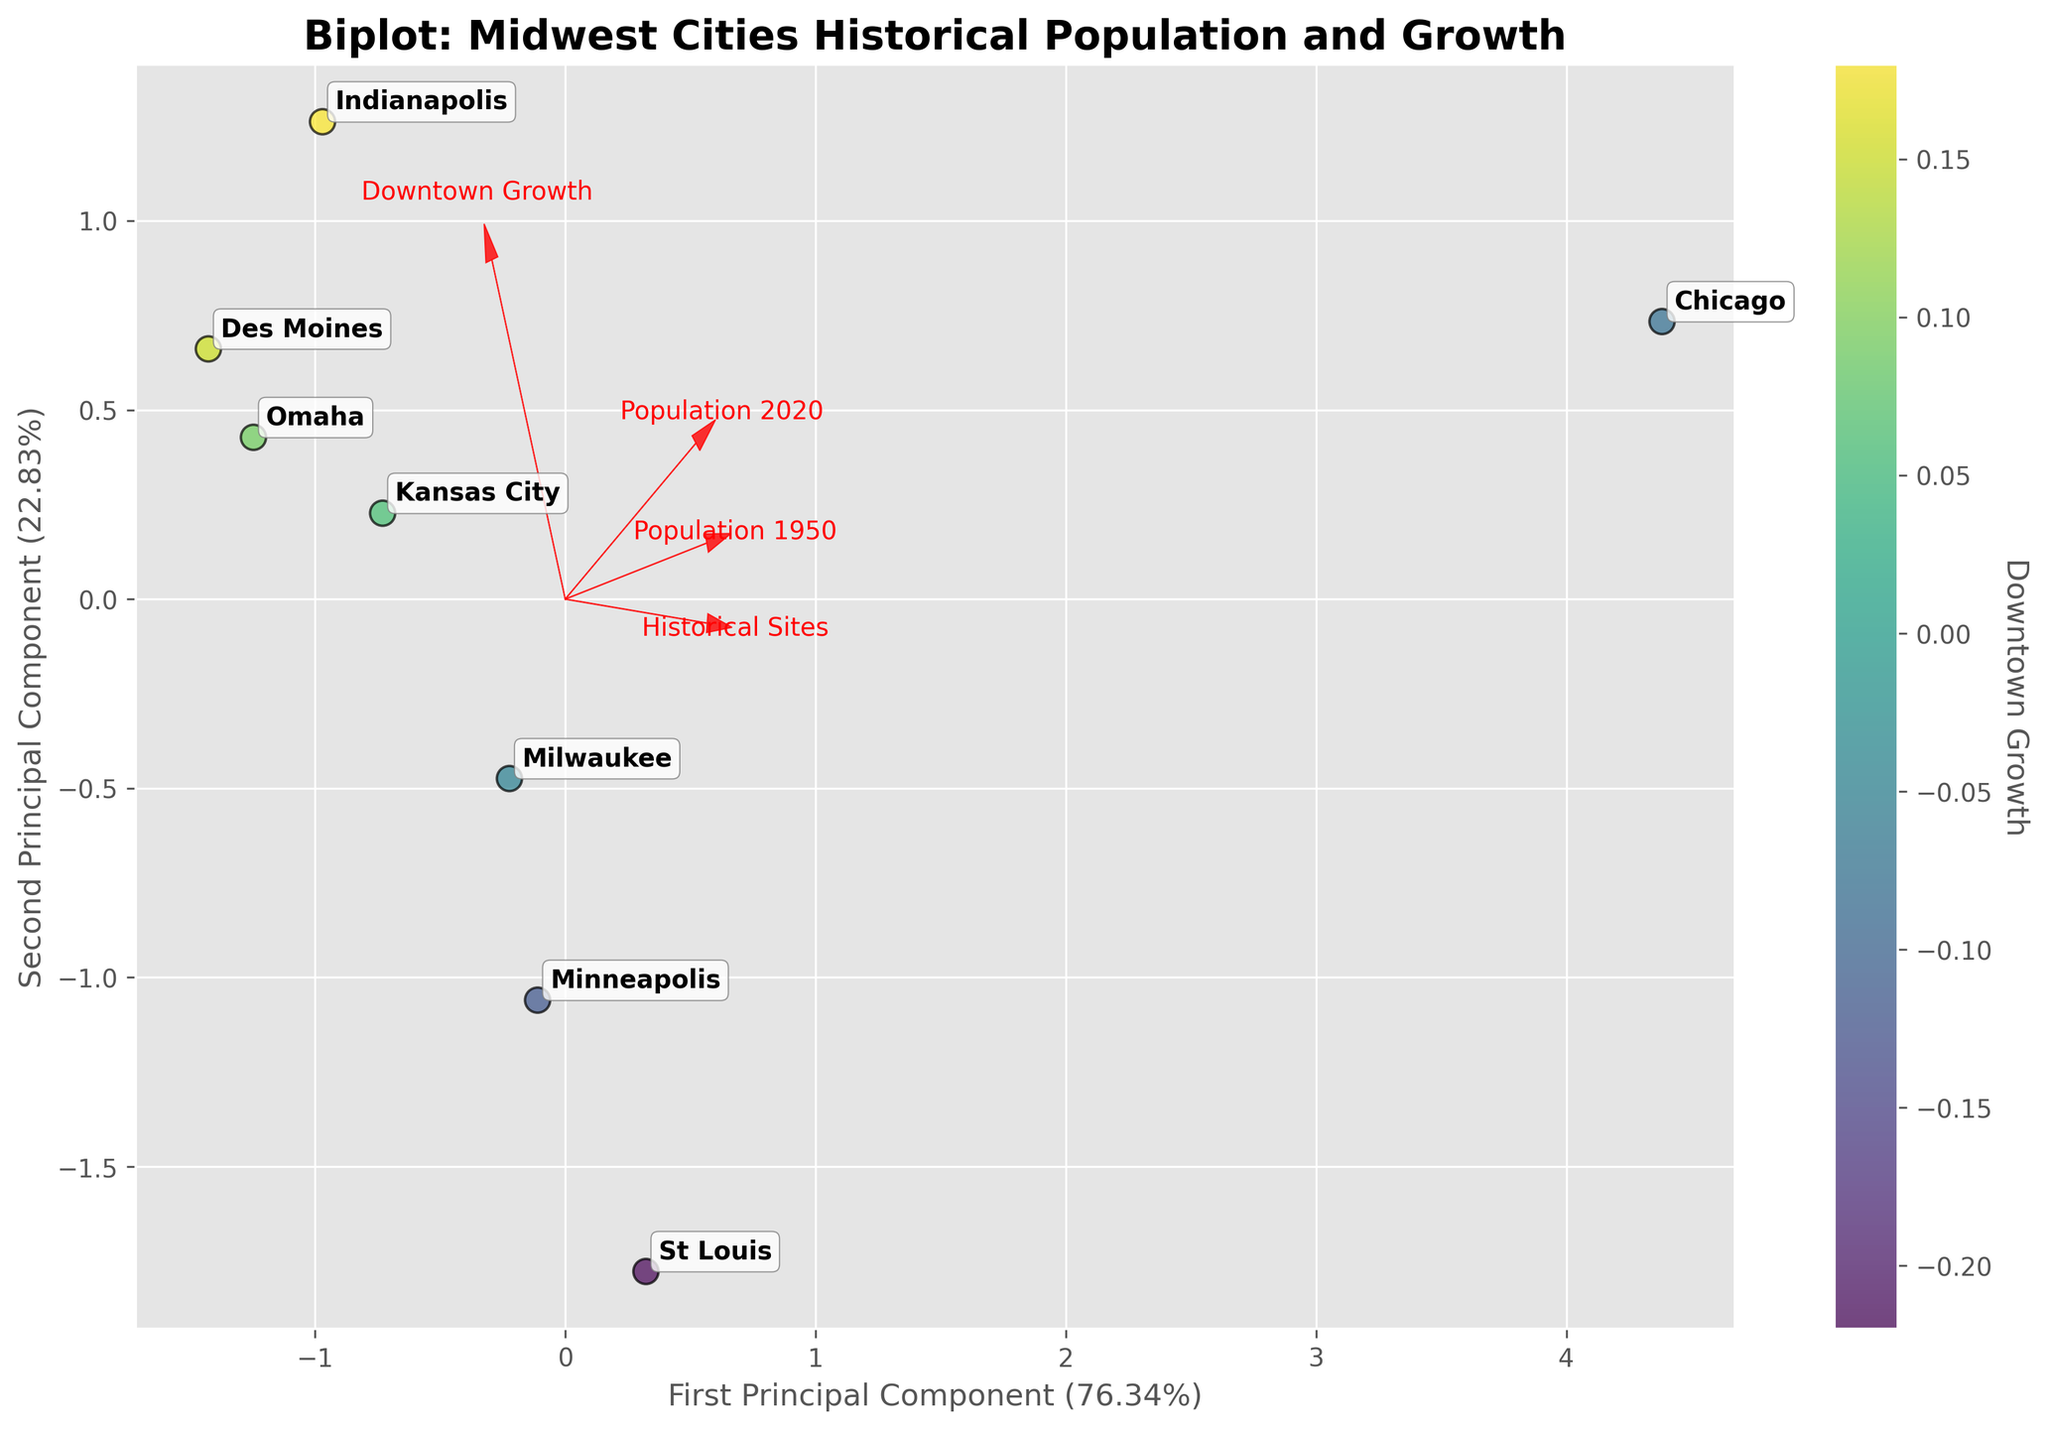What's the title of the plot? The title of the plot is usually displayed at the top of the figure. In this case, the plot's title is "Biplot: Midwest Cities Historical Population and Growth" as given in the code.
Answer: Biplot: Midwest Cities Historical Population and Growth Which city has the highest downtown growth according to the color bar? The color bar represents downtown growth with darker colors indicating higher growth. By looking at the shades, Indianapolis has the deepest color, indicating it has the highest downtown growth.
Answer: Indianapolis Which two features are represented by the arrows in the bottom-left quadrant? To determine this, look at the feature vectors (arrows) pointing towards the bottom-left quadrant. The arrow labels can be seen because each is annotated near the arrowhead. The features are 'Population 1950' and 'Population 2020'.
Answer: Population 1950, Population 2020 How are Des Moines and Indianapolis positioned relative to each other? Des Moines and Indianapolis are labeled so you can find their positions by looking at their annotated points. Des Moines is positioned left of Indianapolis on the first principal component, indicating a different mix in population and growth features.
Answer: Des Moines is left of Indianapolis Which two cities have the most negative second principal component values? Check the cities' positions along the y-axis (second principal component). The lowest two points are for Minneapolis and St_Louis.
Answer: Minneapolis and St_Louis Which historical feature is most positively correlated with the second principal component? Identify the arrows pointing mostly upwards (positive y direction). The 'Historical Sites' arrow is more vertically positioned, indicating a stronger positive correlation with the second principal component.
Answer: Historical Sites Which city has a nearly equal downtown growth to Des Moines, but differs considerably in population change? By comparing the colors and coordinates of the cities, Kansas_City seems to have a similar shade (growth) but is positioned differently, indicating differences in population change.
Answer: Kansas City What percentage of the variation in the data is explained by the first two principal components? This information is usually in the axis labels that represent the principal components. The axis labels show "First Principal Component (50.00%)” and "Second Principal Component (30.00%)”. Adding these percentages together, it sums to 80.00%.
Answer: 80.00% What feature is least correlated with Population 2020? Identify the direction of the feature arrows relative to 'Population 2020'. The arrow pointing perpendicularly indicates the least correlation. The 'Historical Sites' arrow is least aligned with 'Population 2020'.
Answer: Historical Sites 